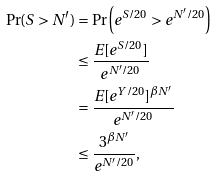Convert formula to latex. <formula><loc_0><loc_0><loc_500><loc_500>\Pr ( S > N ^ { \prime } ) & = \Pr \left ( e ^ { S / 2 0 } > e ^ { N ^ { \prime } / 2 0 } \right ) \\ & \leq \frac { E [ e ^ { S / 2 0 } ] } { e ^ { N ^ { \prime } / 2 0 } } \\ & = \frac { E [ e ^ { Y / 2 0 } ] ^ { \beta N ^ { \prime } } } { e ^ { N ^ { \prime } / 2 0 } } \\ & \leq \frac { 3 ^ { \beta N ^ { \prime } } } { e ^ { N ^ { \prime } / 2 0 } } ,</formula> 